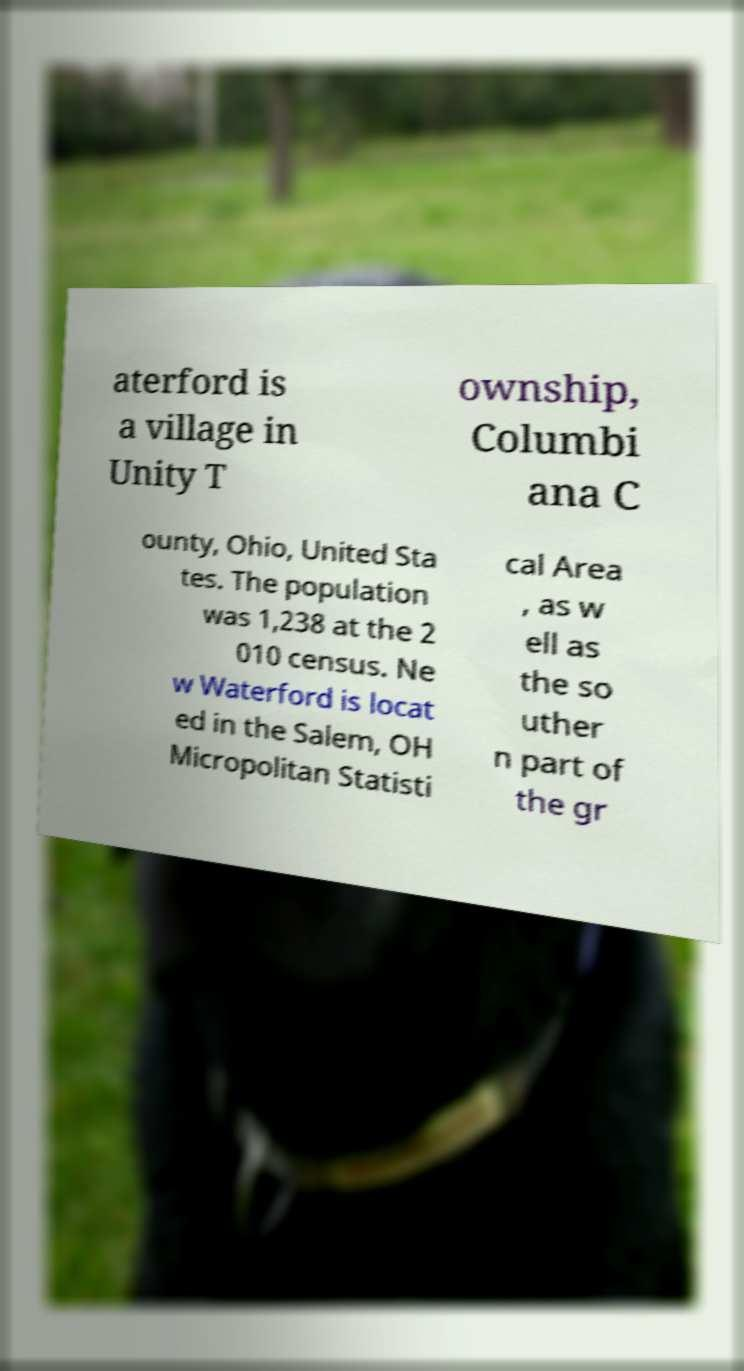For documentation purposes, I need the text within this image transcribed. Could you provide that? aterford is a village in Unity T ownship, Columbi ana C ounty, Ohio, United Sta tes. The population was 1,238 at the 2 010 census. Ne w Waterford is locat ed in the Salem, OH Micropolitan Statisti cal Area , as w ell as the so uther n part of the gr 